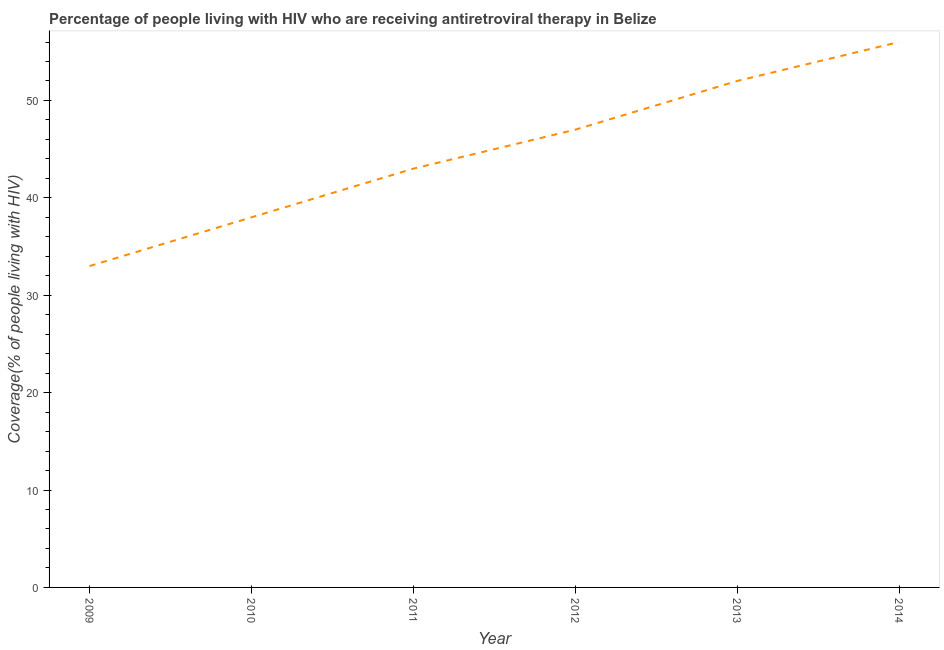What is the antiretroviral therapy coverage in 2014?
Provide a short and direct response. 56. Across all years, what is the maximum antiretroviral therapy coverage?
Keep it short and to the point. 56. Across all years, what is the minimum antiretroviral therapy coverage?
Your response must be concise. 33. What is the sum of the antiretroviral therapy coverage?
Provide a succinct answer. 269. What is the difference between the antiretroviral therapy coverage in 2012 and 2013?
Provide a succinct answer. -5. What is the average antiretroviral therapy coverage per year?
Give a very brief answer. 44.83. Do a majority of the years between 2012 and 2014 (inclusive) have antiretroviral therapy coverage greater than 8 %?
Provide a short and direct response. Yes. What is the ratio of the antiretroviral therapy coverage in 2013 to that in 2014?
Your answer should be very brief. 0.93. Is the sum of the antiretroviral therapy coverage in 2011 and 2014 greater than the maximum antiretroviral therapy coverage across all years?
Offer a terse response. Yes. What is the difference between the highest and the lowest antiretroviral therapy coverage?
Your answer should be compact. 23. Does the antiretroviral therapy coverage monotonically increase over the years?
Your answer should be compact. Yes. How many years are there in the graph?
Provide a short and direct response. 6. Are the values on the major ticks of Y-axis written in scientific E-notation?
Give a very brief answer. No. Does the graph contain grids?
Keep it short and to the point. No. What is the title of the graph?
Your answer should be very brief. Percentage of people living with HIV who are receiving antiretroviral therapy in Belize. What is the label or title of the Y-axis?
Your answer should be compact. Coverage(% of people living with HIV). What is the Coverage(% of people living with HIV) in 2009?
Your answer should be very brief. 33. What is the Coverage(% of people living with HIV) in 2010?
Provide a short and direct response. 38. What is the Coverage(% of people living with HIV) of 2011?
Your answer should be very brief. 43. What is the Coverage(% of people living with HIV) of 2012?
Give a very brief answer. 47. What is the Coverage(% of people living with HIV) in 2013?
Keep it short and to the point. 52. What is the Coverage(% of people living with HIV) in 2014?
Keep it short and to the point. 56. What is the difference between the Coverage(% of people living with HIV) in 2009 and 2011?
Ensure brevity in your answer.  -10. What is the difference between the Coverage(% of people living with HIV) in 2009 and 2012?
Give a very brief answer. -14. What is the difference between the Coverage(% of people living with HIV) in 2009 and 2014?
Your answer should be compact. -23. What is the difference between the Coverage(% of people living with HIV) in 2010 and 2013?
Your response must be concise. -14. What is the difference between the Coverage(% of people living with HIV) in 2010 and 2014?
Ensure brevity in your answer.  -18. What is the difference between the Coverage(% of people living with HIV) in 2011 and 2012?
Make the answer very short. -4. What is the difference between the Coverage(% of people living with HIV) in 2011 and 2013?
Ensure brevity in your answer.  -9. What is the difference between the Coverage(% of people living with HIV) in 2011 and 2014?
Your answer should be compact. -13. What is the difference between the Coverage(% of people living with HIV) in 2012 and 2013?
Your answer should be very brief. -5. What is the difference between the Coverage(% of people living with HIV) in 2012 and 2014?
Your answer should be compact. -9. What is the difference between the Coverage(% of people living with HIV) in 2013 and 2014?
Make the answer very short. -4. What is the ratio of the Coverage(% of people living with HIV) in 2009 to that in 2010?
Offer a very short reply. 0.87. What is the ratio of the Coverage(% of people living with HIV) in 2009 to that in 2011?
Offer a very short reply. 0.77. What is the ratio of the Coverage(% of people living with HIV) in 2009 to that in 2012?
Offer a terse response. 0.7. What is the ratio of the Coverage(% of people living with HIV) in 2009 to that in 2013?
Provide a succinct answer. 0.64. What is the ratio of the Coverage(% of people living with HIV) in 2009 to that in 2014?
Your answer should be very brief. 0.59. What is the ratio of the Coverage(% of people living with HIV) in 2010 to that in 2011?
Keep it short and to the point. 0.88. What is the ratio of the Coverage(% of people living with HIV) in 2010 to that in 2012?
Give a very brief answer. 0.81. What is the ratio of the Coverage(% of people living with HIV) in 2010 to that in 2013?
Ensure brevity in your answer.  0.73. What is the ratio of the Coverage(% of people living with HIV) in 2010 to that in 2014?
Provide a succinct answer. 0.68. What is the ratio of the Coverage(% of people living with HIV) in 2011 to that in 2012?
Provide a short and direct response. 0.92. What is the ratio of the Coverage(% of people living with HIV) in 2011 to that in 2013?
Make the answer very short. 0.83. What is the ratio of the Coverage(% of people living with HIV) in 2011 to that in 2014?
Give a very brief answer. 0.77. What is the ratio of the Coverage(% of people living with HIV) in 2012 to that in 2013?
Provide a short and direct response. 0.9. What is the ratio of the Coverage(% of people living with HIV) in 2012 to that in 2014?
Offer a very short reply. 0.84. What is the ratio of the Coverage(% of people living with HIV) in 2013 to that in 2014?
Your answer should be compact. 0.93. 